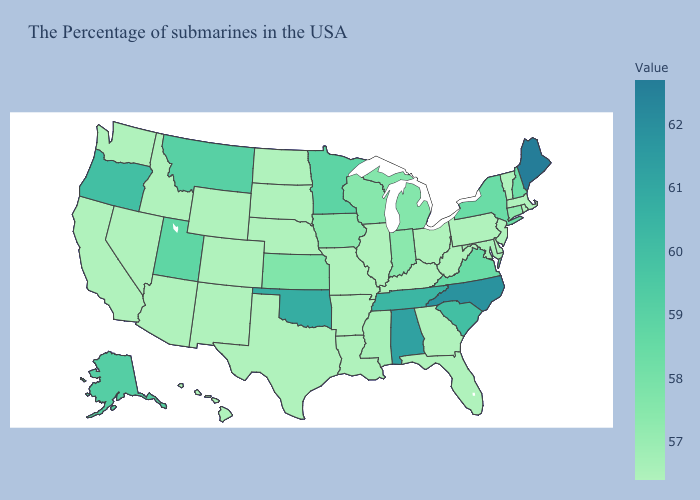Which states have the highest value in the USA?
Give a very brief answer. Maine. Does Michigan have the highest value in the USA?
Answer briefly. No. Which states hav the highest value in the MidWest?
Keep it brief. Minnesota. Which states have the lowest value in the West?
Write a very short answer. Wyoming, Colorado, New Mexico, Arizona, Idaho, Nevada, California, Washington, Hawaii. Does New York have the lowest value in the USA?
Be succinct. No. Does Maine have the highest value in the Northeast?
Keep it brief. Yes. 